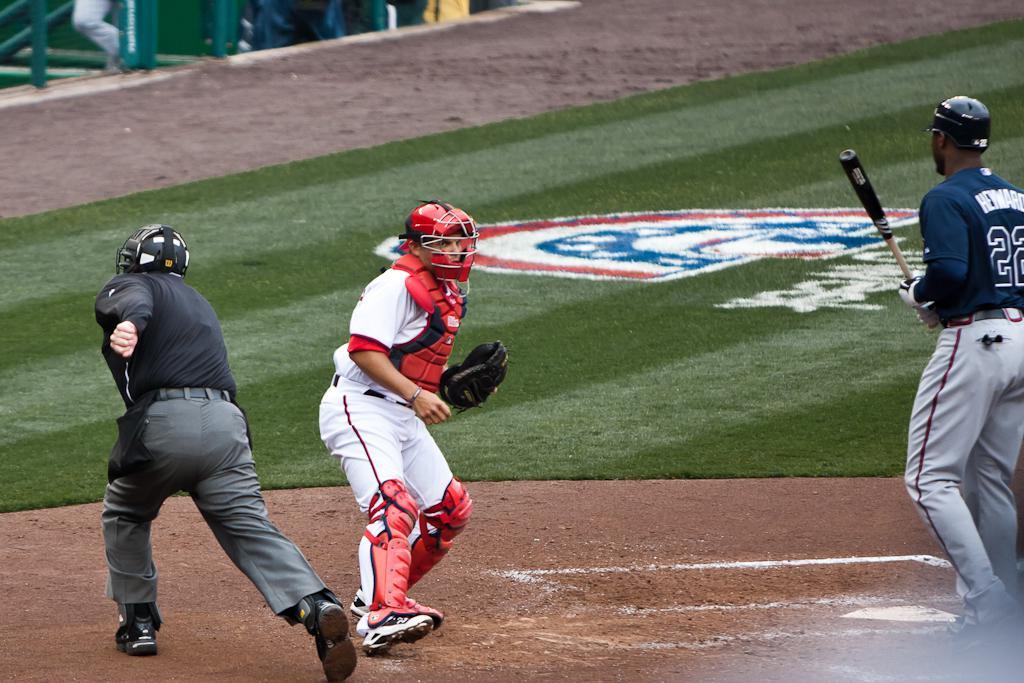What jersey number is seen on the dark blue jersey?
Ensure brevity in your answer.  22. What does the batters last name start with?
Provide a short and direct response. H. 